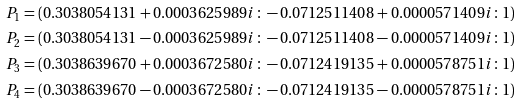Convert formula to latex. <formula><loc_0><loc_0><loc_500><loc_500>P _ { 1 } & = ( 0 . 3 0 3 8 0 5 4 1 3 1 + 0 . 0 0 0 3 6 2 5 9 8 9 i \colon - 0 . 0 7 1 2 5 1 1 4 0 8 + 0 . 0 0 0 0 5 7 1 4 0 9 i \colon 1 ) \\ P _ { 2 } & = ( 0 . 3 0 3 8 0 5 4 1 3 1 - 0 . 0 0 0 3 6 2 5 9 8 9 i \colon - 0 . 0 7 1 2 5 1 1 4 0 8 - 0 . 0 0 0 0 5 7 1 4 0 9 i \colon 1 ) \\ P _ { 3 } & = ( 0 . 3 0 3 8 6 3 9 6 7 0 + 0 . 0 0 0 3 6 7 2 5 8 0 i \colon - 0 . 0 7 1 2 4 1 9 1 3 5 + 0 . 0 0 0 0 5 7 8 7 5 1 i \colon 1 ) \\ P _ { 4 } & = ( 0 . 3 0 3 8 6 3 9 6 7 0 - 0 . 0 0 0 3 6 7 2 5 8 0 i \colon - 0 . 0 7 1 2 4 1 9 1 3 5 - 0 . 0 0 0 0 5 7 8 7 5 1 i \colon 1 )</formula> 